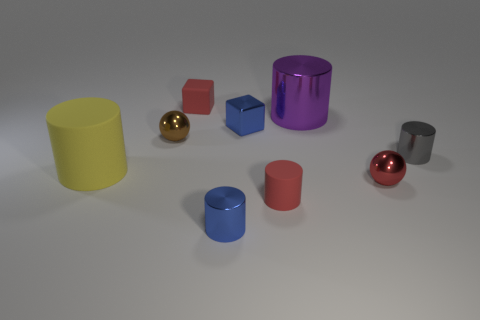Subtract all tiny red matte cylinders. How many cylinders are left? 4 Subtract all blue cylinders. How many cylinders are left? 4 Subtract 1 cylinders. How many cylinders are left? 4 Subtract all yellow cylinders. Subtract all purple cubes. How many cylinders are left? 4 Subtract all green cylinders. How many green blocks are left? 0 Subtract all purple metallic cylinders. Subtract all purple cylinders. How many objects are left? 7 Add 1 small blue things. How many small blue things are left? 3 Add 7 green cylinders. How many green cylinders exist? 7 Subtract 0 gray cubes. How many objects are left? 9 Subtract all balls. How many objects are left? 7 